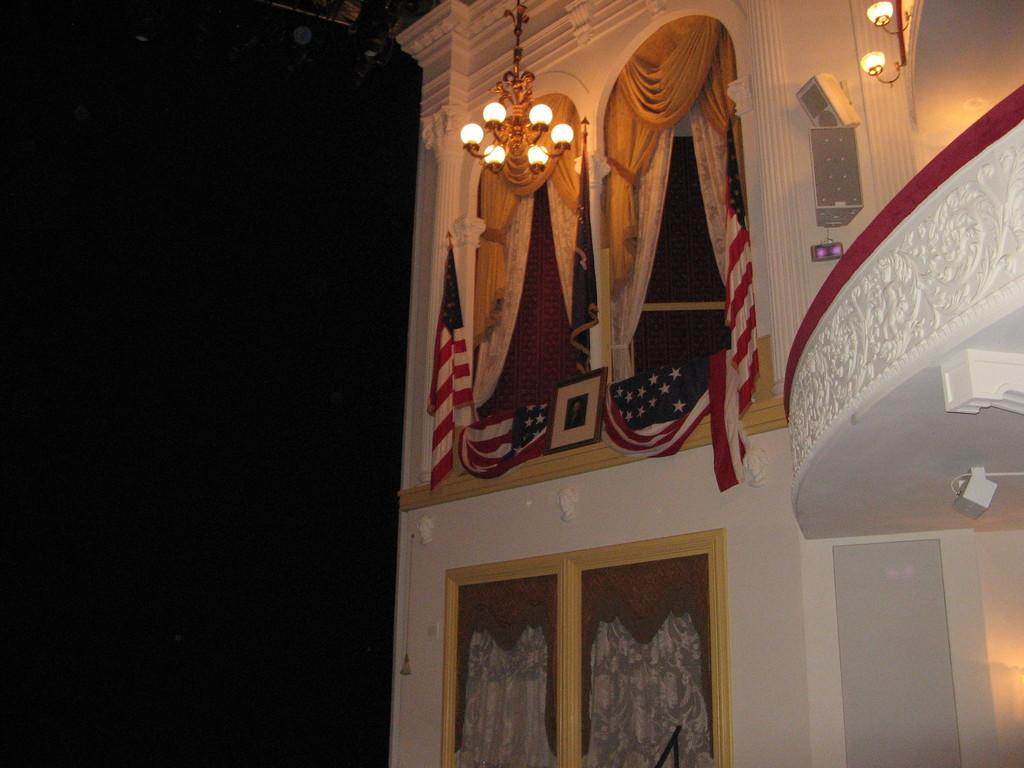What type of structure is visible in the image? There is a building in the image. What decorative elements are present on the building? The building has flags and curtains. What feature of the building is visible at night? The building has lights. What can be seen on the left side of the image? There is a black background on the left side of the image. What type of furniture can be seen in the image? There is no furniture present in the image; it features a building with flags, curtains, and lights. Is there a hospital visible in the image? There is no indication in the image that it is a hospital; it is a building with flags, curtains, and lights. 